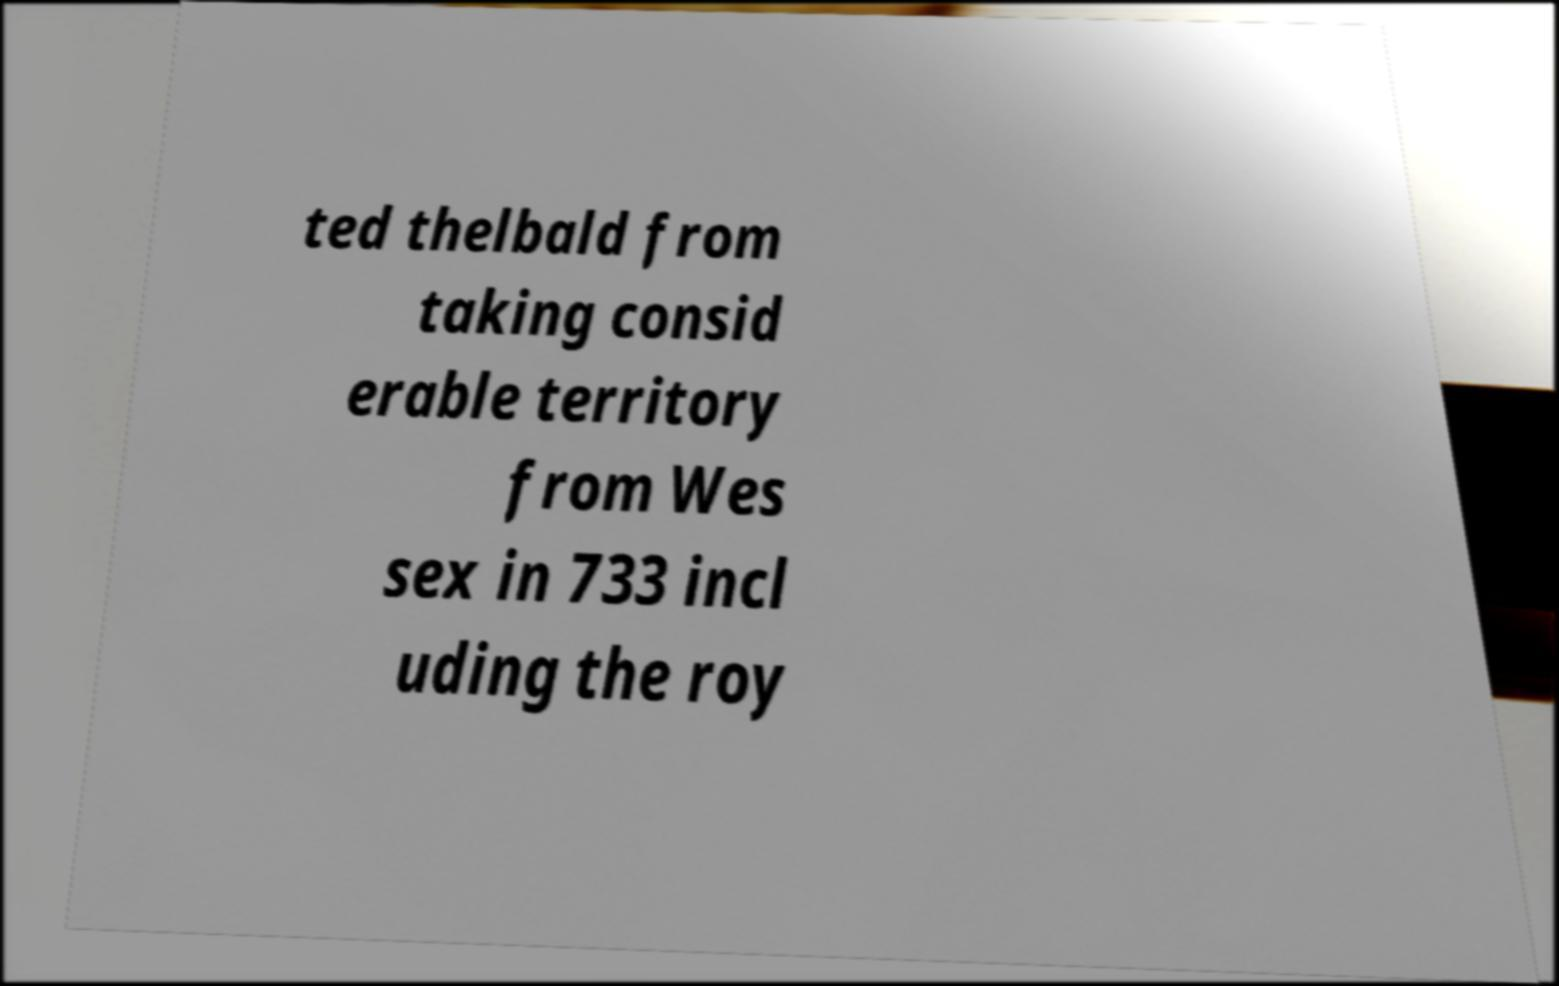Can you read and provide the text displayed in the image?This photo seems to have some interesting text. Can you extract and type it out for me? ted thelbald from taking consid erable territory from Wes sex in 733 incl uding the roy 